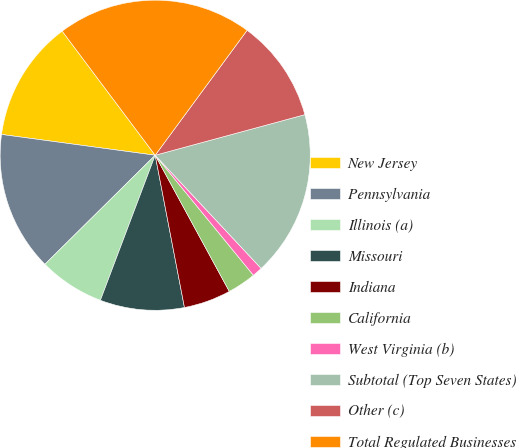<chart> <loc_0><loc_0><loc_500><loc_500><pie_chart><fcel>New Jersey<fcel>Pennsylvania<fcel>Illinois (a)<fcel>Missouri<fcel>Indiana<fcel>California<fcel>West Virginia (b)<fcel>Subtotal (Top Seven States)<fcel>Other (c)<fcel>Total Regulated Businesses<nl><fcel>12.62%<fcel>14.55%<fcel>6.84%<fcel>8.77%<fcel>4.91%<fcel>2.98%<fcel>1.06%<fcel>17.24%<fcel>10.69%<fcel>20.33%<nl></chart> 